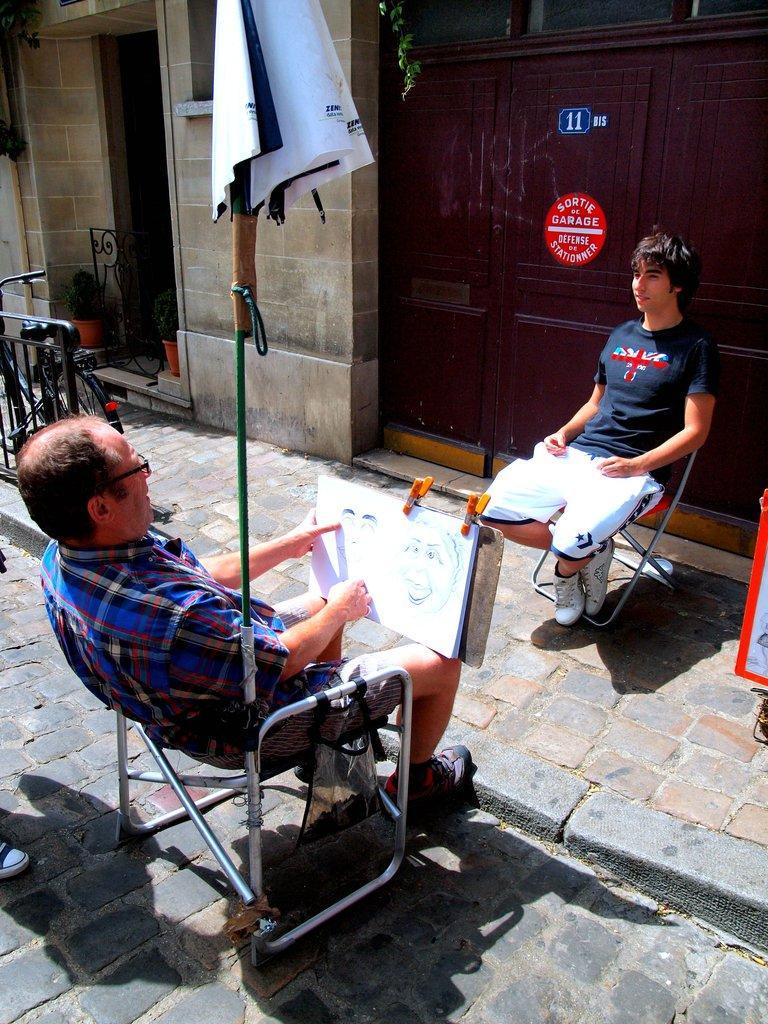How would you summarize this image in a sentence or two? This is a picture taken in the outdoors. It is sunny. There are two persons sitting on chairs. The man in checks shirt was holding a paper and drawing a picture to his chair there is a umbrella. Behind the people there is a wooden door, wall and a bicycle. 